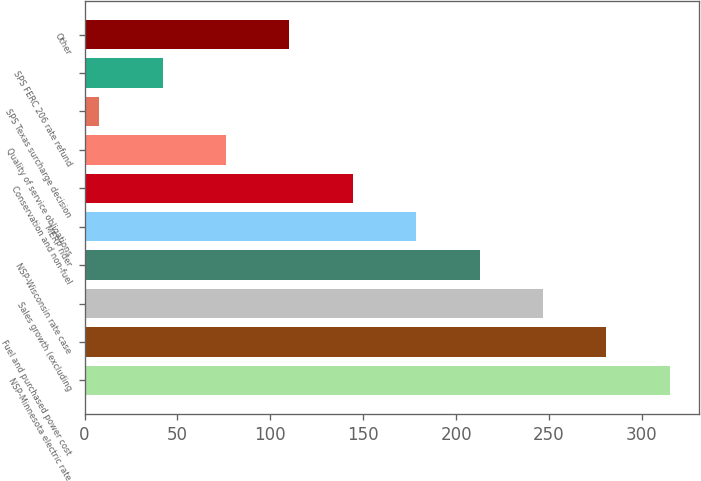<chart> <loc_0><loc_0><loc_500><loc_500><bar_chart><fcel>NSP-Minnesota electric rate<fcel>Fuel and purchased power cost<fcel>Sales growth (excluding<fcel>NSP-Wisconsin rate case<fcel>MERP rider<fcel>Conservation and non-fuel<fcel>Quality of service obligations<fcel>SPS Texas surcharge decision<fcel>SPS FERC 206 rate refund<fcel>Other<nl><fcel>314.9<fcel>280.8<fcel>246.7<fcel>212.6<fcel>178.5<fcel>144.4<fcel>76.2<fcel>8<fcel>42.1<fcel>110.3<nl></chart> 